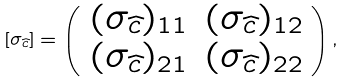Convert formula to latex. <formula><loc_0><loc_0><loc_500><loc_500>[ \sigma _ { \widehat { c } } ] = \left ( \begin{array} { c c } ( \sigma _ { \widehat { c } } ) _ { 1 1 } & ( \sigma _ { \widehat { c } } ) _ { 1 2 } \\ ( \sigma _ { \widehat { c } } ) _ { 2 1 } & ( \sigma _ { \widehat { c } } ) _ { 2 2 } \end{array} \right ) ,</formula> 